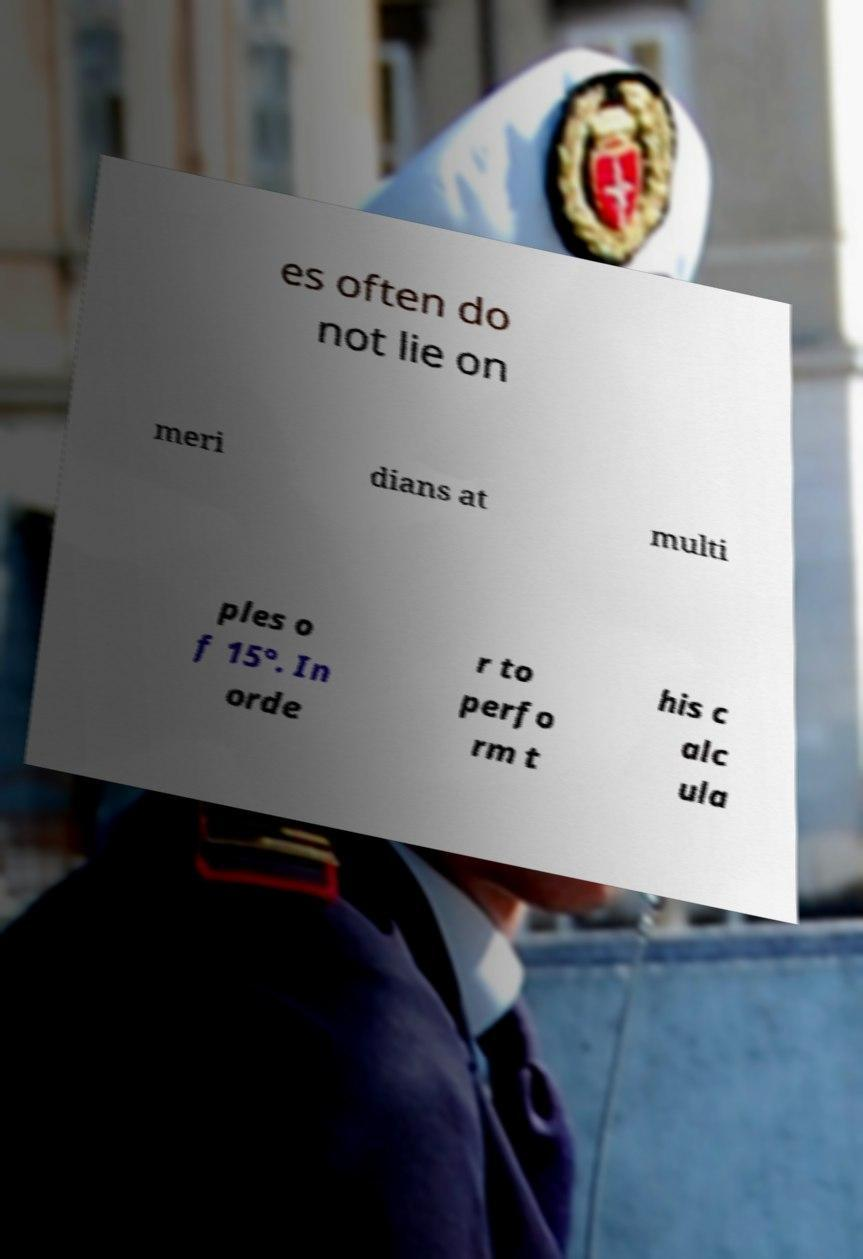For documentation purposes, I need the text within this image transcribed. Could you provide that? es often do not lie on meri dians at multi ples o f 15°. In orde r to perfo rm t his c alc ula 